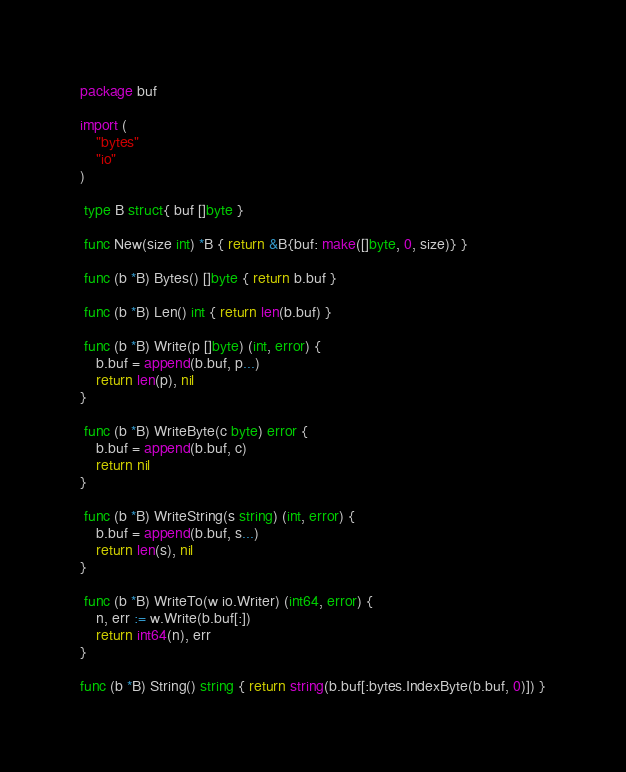<code> <loc_0><loc_0><loc_500><loc_500><_Go_>package buf

import (
	"bytes"
	"io"
)	

 type B struct{ buf []byte }	
 
 func New(size int) *B { return &B{buf: make([]byte, 0, size)} }	
 
 func (b *B) Bytes() []byte { return b.buf }	
 
 func (b *B) Len() int { return len(b.buf) }	
 
 func (b *B) Write(p []byte) (int, error) {	
	b.buf = append(b.buf, p...)	
	return len(p), nil	
}	

 func (b *B) WriteByte(c byte) error {	
	b.buf = append(b.buf, c)	
	return nil	
}	

 func (b *B) WriteString(s string) (int, error) {	
	b.buf = append(b.buf, s...)	
	return len(s), nil	
}	

 func (b *B) WriteTo(w io.Writer) (int64, error) {	
	n, err := w.Write(b.buf[:])	
	return int64(n), err	
}

func (b *B) String() string { return string(b.buf[:bytes.IndexByte(b.buf, 0)]) }
</code> 